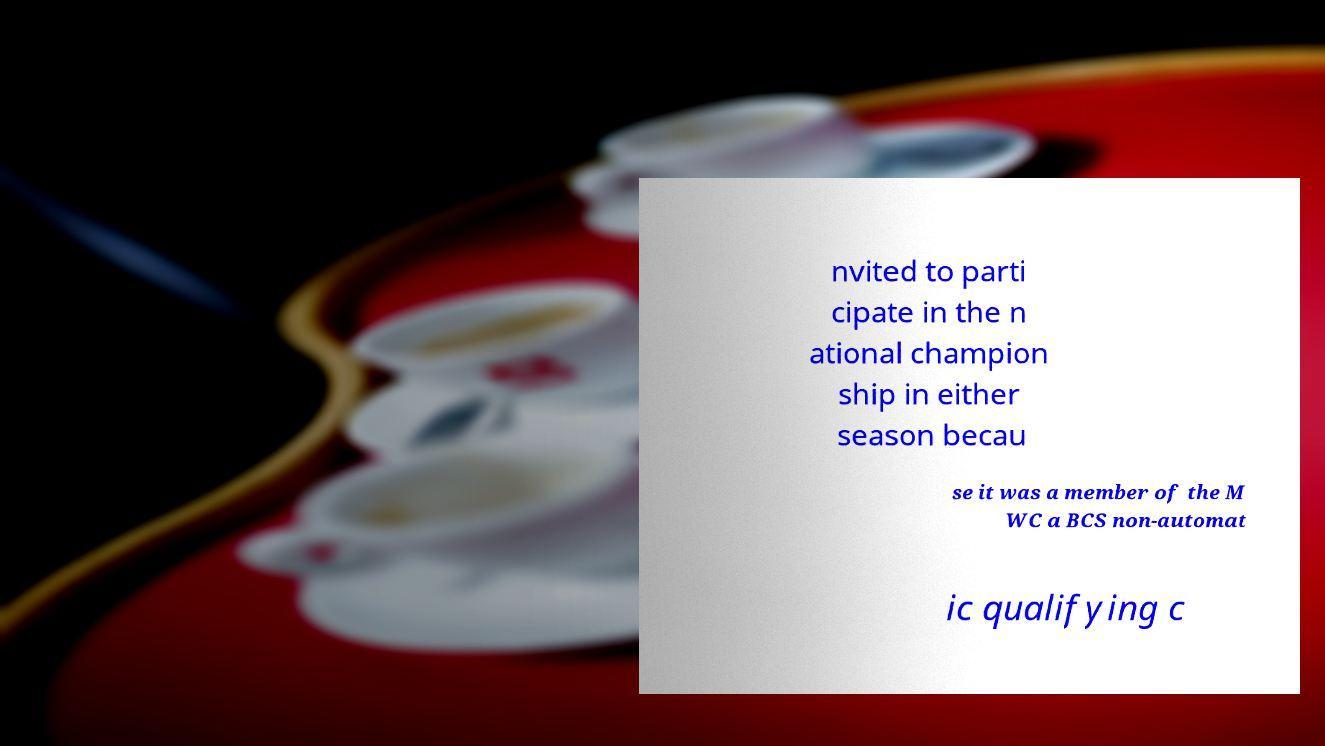What messages or text are displayed in this image? I need them in a readable, typed format. nvited to parti cipate in the n ational champion ship in either season becau se it was a member of the M WC a BCS non-automat ic qualifying c 